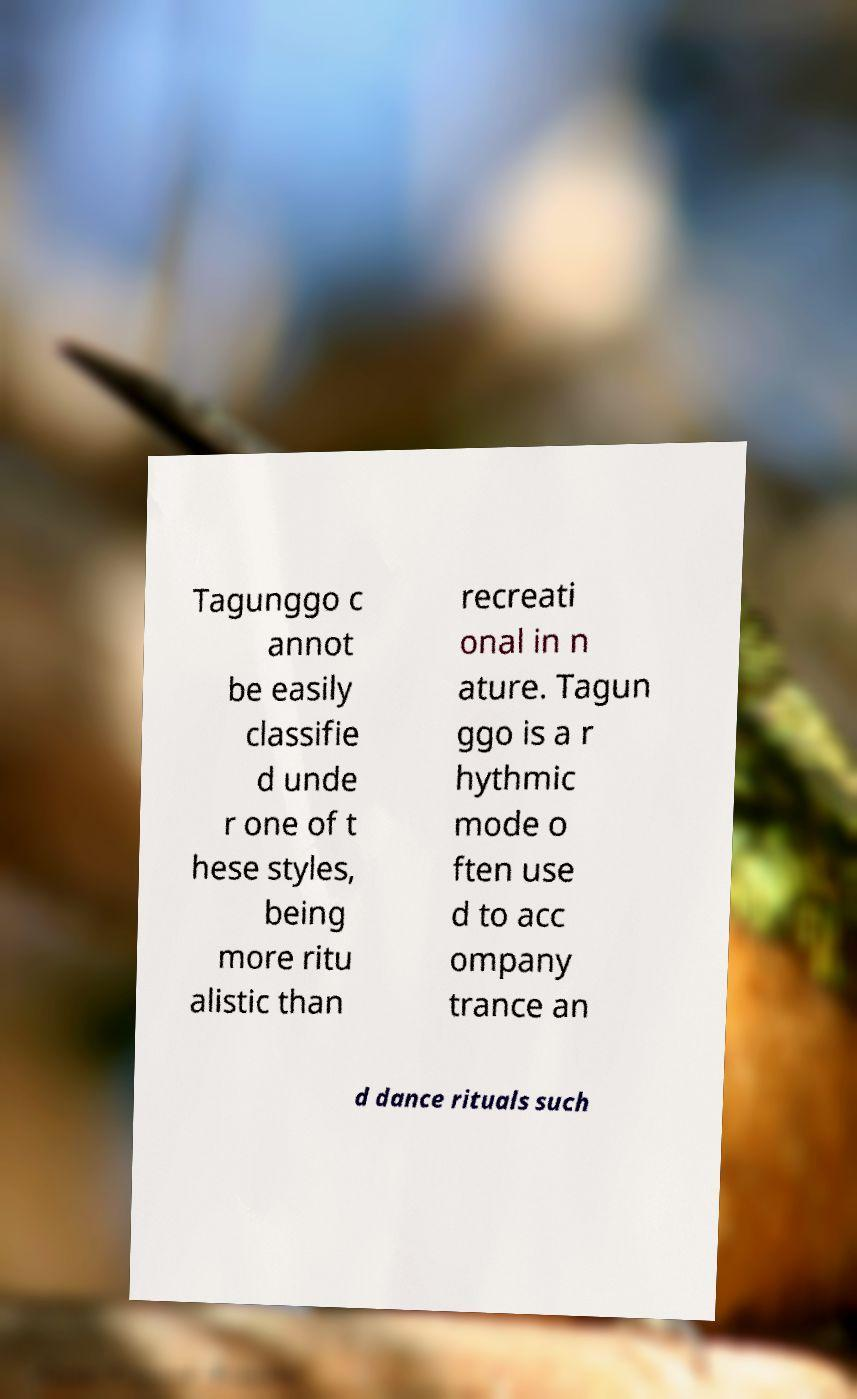Can you read and provide the text displayed in the image?This photo seems to have some interesting text. Can you extract and type it out for me? Tagunggo c annot be easily classifie d unde r one of t hese styles, being more ritu alistic than recreati onal in n ature. Tagun ggo is a r hythmic mode o ften use d to acc ompany trance an d dance rituals such 